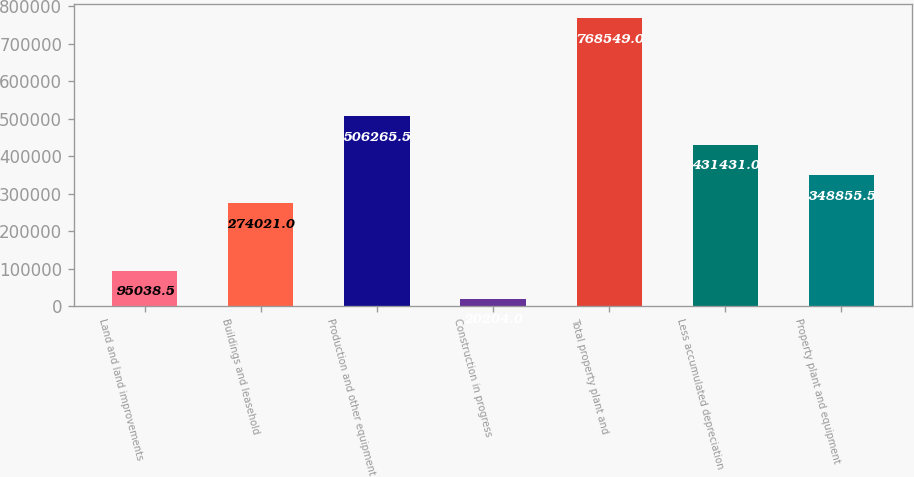<chart> <loc_0><loc_0><loc_500><loc_500><bar_chart><fcel>Land and land improvements<fcel>Buildings and leasehold<fcel>Production and other equipment<fcel>Construction in progress<fcel>Total property plant and<fcel>Less accumulated depreciation<fcel>Property plant and equipment<nl><fcel>95038.5<fcel>274021<fcel>506266<fcel>20204<fcel>768549<fcel>431431<fcel>348856<nl></chart> 